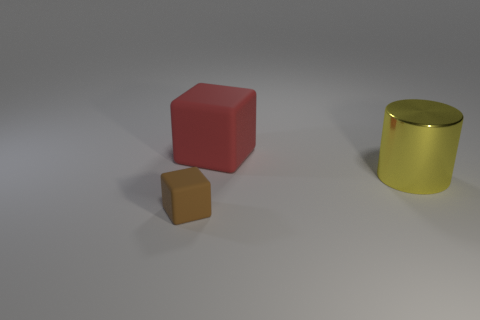Are there any metal cylinders of the same size as the yellow thing?
Offer a very short reply. No. There is a rubber cube in front of the large yellow metallic thing; is its color the same as the thing that is right of the large red matte cube?
Your answer should be very brief. No. Is there a small rubber cylinder that has the same color as the small matte thing?
Keep it short and to the point. No. What number of other things are the same shape as the large matte object?
Keep it short and to the point. 1. There is a big thing that is left of the metallic cylinder; what shape is it?
Offer a terse response. Cube. Do the large metal object and the matte thing to the left of the red object have the same shape?
Ensure brevity in your answer.  No. What size is the object that is both on the left side of the yellow thing and to the right of the small brown rubber object?
Give a very brief answer. Large. What is the color of the object that is left of the large cylinder and to the right of the tiny brown thing?
Your answer should be very brief. Red. Is there anything else that is made of the same material as the cylinder?
Offer a very short reply. No. Is the number of small brown blocks that are on the right side of the yellow thing less than the number of tiny blocks left of the brown rubber thing?
Your answer should be very brief. No. 